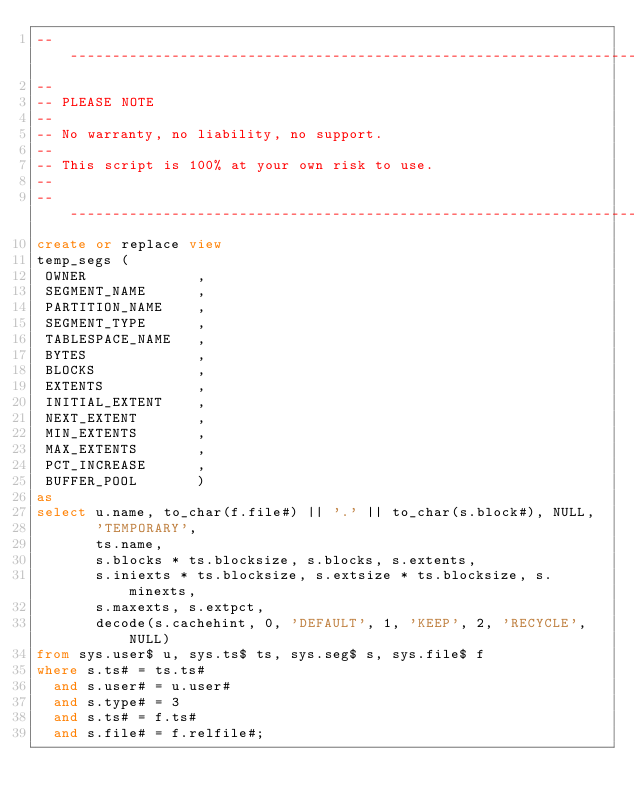<code> <loc_0><loc_0><loc_500><loc_500><_SQL_>-------------------------------------------------------------------------------
--
-- PLEASE NOTE
-- 
-- No warranty, no liability, no support.
--
-- This script is 100% at your own risk to use.
--
-------------------------------------------------------------------------------
create or replace view
temp_segs (
 OWNER             ,
 SEGMENT_NAME      ,
 PARTITION_NAME    ,
 SEGMENT_TYPE      ,
 TABLESPACE_NAME   ,
 BYTES             ,
 BLOCKS            ,
 EXTENTS           ,
 INITIAL_EXTENT    ,
 NEXT_EXTENT       ,
 MIN_EXTENTS       ,
 MAX_EXTENTS       ,
 PCT_INCREASE      ,
 BUFFER_POOL       )
as
select u.name, to_char(f.file#) || '.' || to_char(s.block#), NULL,
       'TEMPORARY',
       ts.name, 
       s.blocks * ts.blocksize, s.blocks, s.extents,
       s.iniexts * ts.blocksize, s.extsize * ts.blocksize, s.minexts,
       s.maxexts, s.extpct,
       decode(s.cachehint, 0, 'DEFAULT', 1, 'KEEP', 2, 'RECYCLE', NULL)
from sys.user$ u, sys.ts$ ts, sys.seg$ s, sys.file$ f
where s.ts# = ts.ts#
  and s.user# = u.user#
  and s.type# = 3
  and s.ts# = f.ts#
  and s.file# = f.relfile#;
</code> 